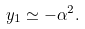<formula> <loc_0><loc_0><loc_500><loc_500>y _ { 1 } \simeq - \alpha ^ { 2 } .</formula> 